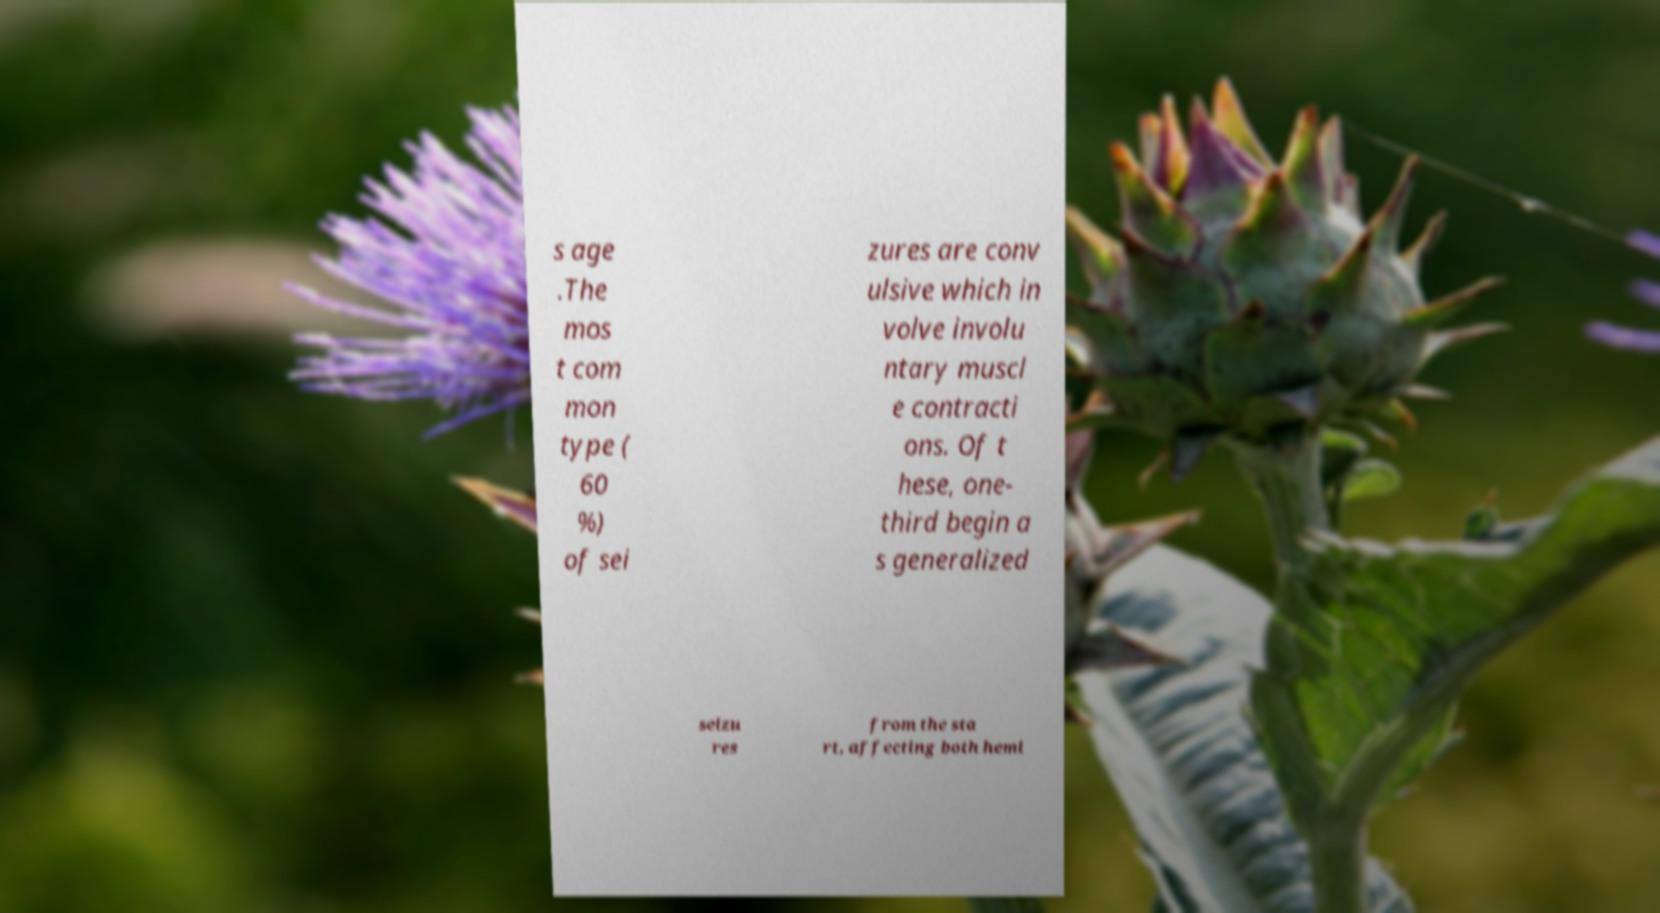Could you assist in decoding the text presented in this image and type it out clearly? s age .The mos t com mon type ( 60 %) of sei zures are conv ulsive which in volve involu ntary muscl e contracti ons. Of t hese, one- third begin a s generalized seizu res from the sta rt, affecting both hemi 